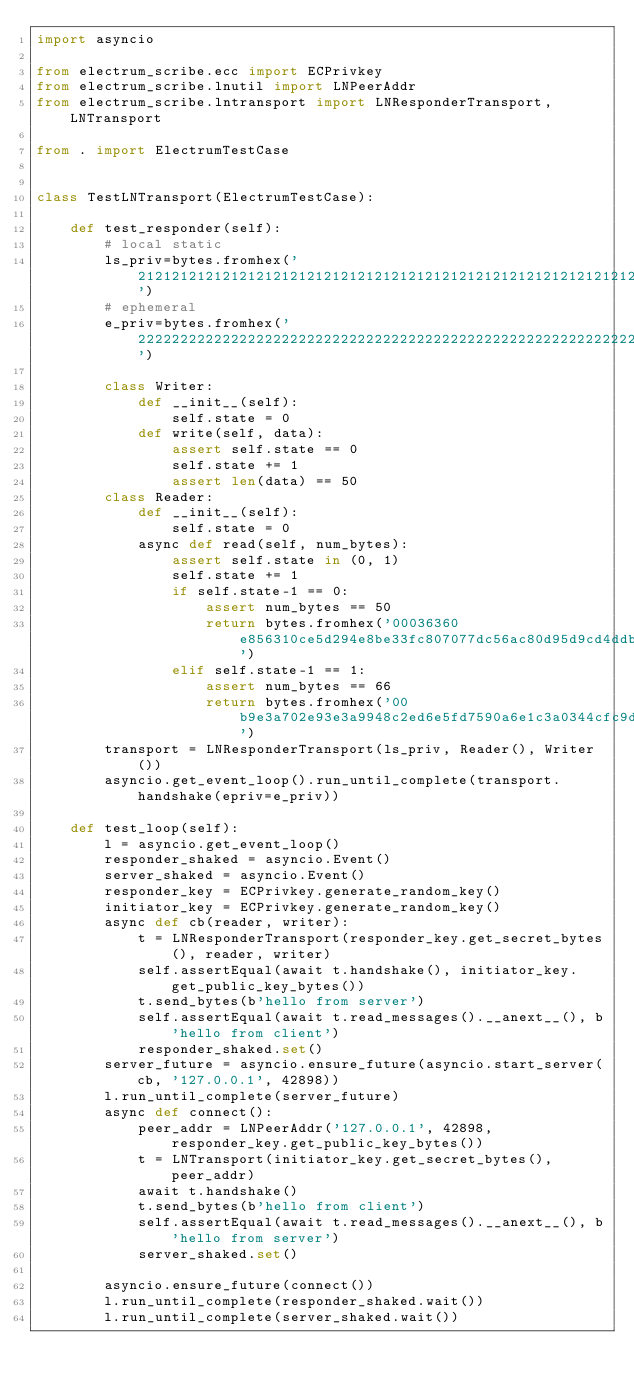Convert code to text. <code><loc_0><loc_0><loc_500><loc_500><_Python_>import asyncio

from electrum_scribe.ecc import ECPrivkey
from electrum_scribe.lnutil import LNPeerAddr
from electrum_scribe.lntransport import LNResponderTransport, LNTransport

from . import ElectrumTestCase


class TestLNTransport(ElectrumTestCase):

    def test_responder(self):
        # local static
        ls_priv=bytes.fromhex('2121212121212121212121212121212121212121212121212121212121212121')
        # ephemeral
        e_priv=bytes.fromhex('2222222222222222222222222222222222222222222222222222222222222222')

        class Writer:
            def __init__(self):
                self.state = 0
            def write(self, data):
                assert self.state == 0
                self.state += 1
                assert len(data) == 50
        class Reader:
            def __init__(self):
                self.state = 0
            async def read(self, num_bytes):
                assert self.state in (0, 1)
                self.state += 1
                if self.state-1 == 0:
                    assert num_bytes == 50
                    return bytes.fromhex('00036360e856310ce5d294e8be33fc807077dc56ac80d95d9cd4ddbd21325eff73f70df6086551151f58b8afe6c195782c6a')
                elif self.state-1 == 1:
                    assert num_bytes == 66
                    return bytes.fromhex('00b9e3a702e93e3a9948c2ed6e5fd7590a6e1c3a0344cfc9d5b57357049aa22355361aa02e55a8fc28fef5bd6d71ad0c38228dc68b1c466263b47fdf31e560e139ba')
        transport = LNResponderTransport(ls_priv, Reader(), Writer())
        asyncio.get_event_loop().run_until_complete(transport.handshake(epriv=e_priv))

    def test_loop(self):
        l = asyncio.get_event_loop()
        responder_shaked = asyncio.Event()
        server_shaked = asyncio.Event()
        responder_key = ECPrivkey.generate_random_key()
        initiator_key = ECPrivkey.generate_random_key()
        async def cb(reader, writer):
            t = LNResponderTransport(responder_key.get_secret_bytes(), reader, writer)
            self.assertEqual(await t.handshake(), initiator_key.get_public_key_bytes())
            t.send_bytes(b'hello from server')
            self.assertEqual(await t.read_messages().__anext__(), b'hello from client')
            responder_shaked.set()
        server_future = asyncio.ensure_future(asyncio.start_server(cb, '127.0.0.1', 42898))
        l.run_until_complete(server_future)
        async def connect():
            peer_addr = LNPeerAddr('127.0.0.1', 42898, responder_key.get_public_key_bytes())
            t = LNTransport(initiator_key.get_secret_bytes(), peer_addr)
            await t.handshake()
            t.send_bytes(b'hello from client')
            self.assertEqual(await t.read_messages().__anext__(), b'hello from server')
            server_shaked.set()

        asyncio.ensure_future(connect())
        l.run_until_complete(responder_shaked.wait())
        l.run_until_complete(server_shaked.wait())
</code> 